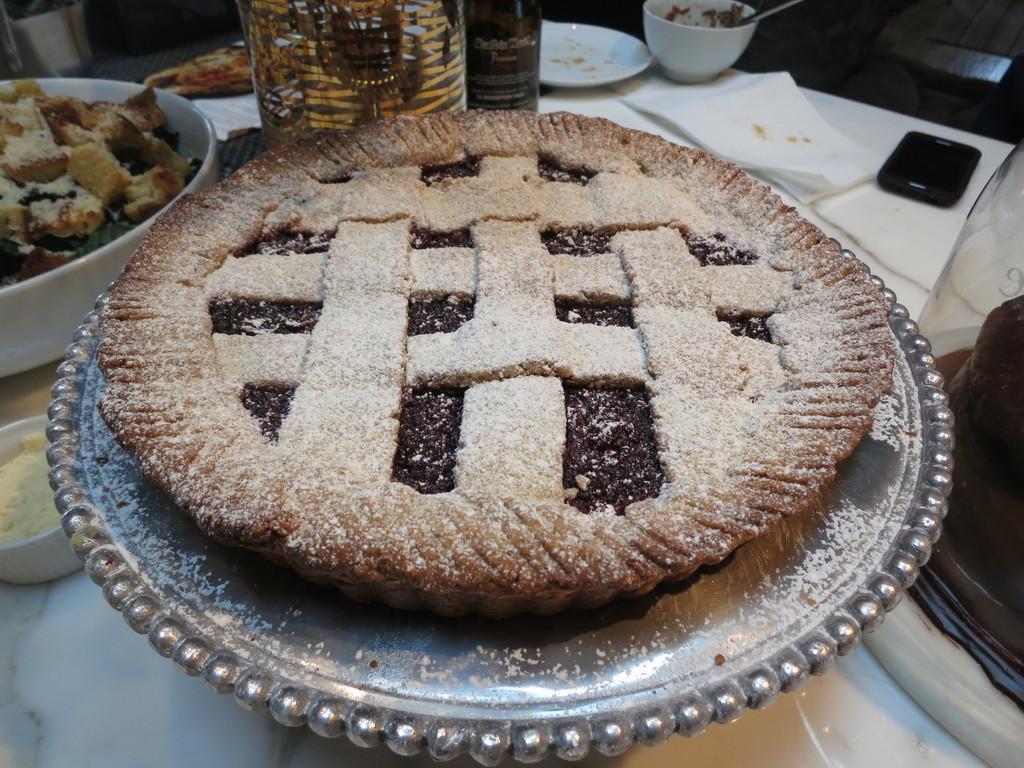Describe this image in one or two sentences. In this image I can see plates, bowls , bottles, tissue papers , phone kept on table , on the top of plate I can see food item. 